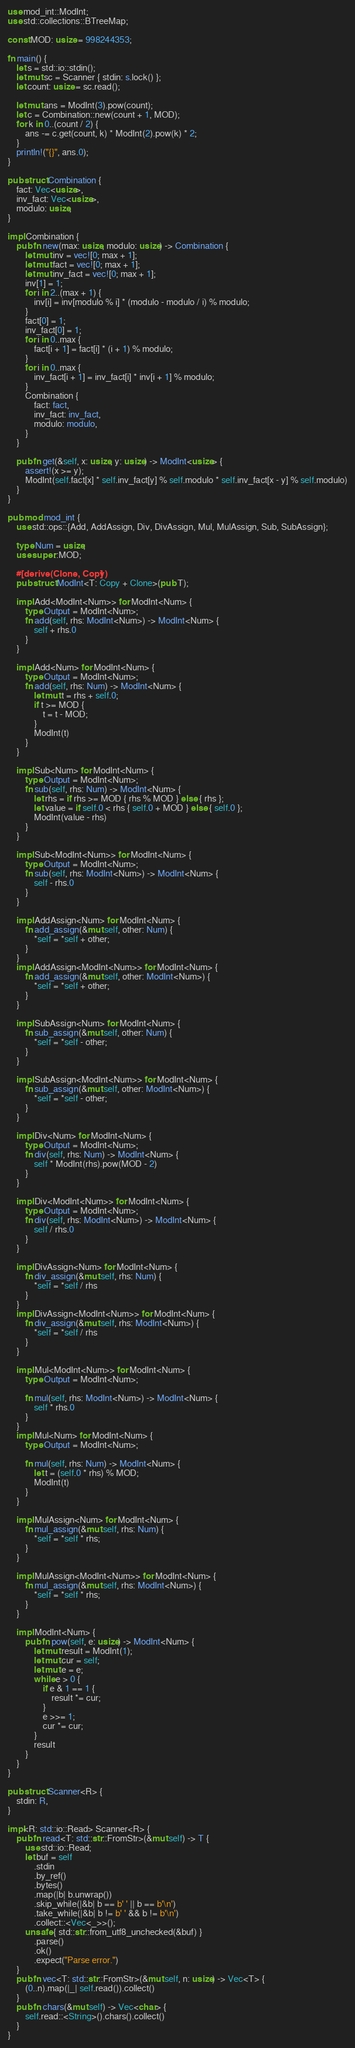<code> <loc_0><loc_0><loc_500><loc_500><_Rust_>use mod_int::ModInt;
use std::collections::BTreeMap;

const MOD: usize = 998244353;

fn main() {
    let s = std::io::stdin();
    let mut sc = Scanner { stdin: s.lock() };
    let count: usize = sc.read();

    let mut ans = ModInt(3).pow(count);
    let c = Combination::new(count + 1, MOD);
    for k in 0..(count / 2) {
        ans -= c.get(count, k) * ModInt(2).pow(k) * 2;
    }
    println!("{}", ans.0);
}

pub struct Combination {
    fact: Vec<usize>,
    inv_fact: Vec<usize>,
    modulo: usize,
}

impl Combination {
    pub fn new(max: usize, modulo: usize) -> Combination {
        let mut inv = vec![0; max + 1];
        let mut fact = vec![0; max + 1];
        let mut inv_fact = vec![0; max + 1];
        inv[1] = 1;
        for i in 2..(max + 1) {
            inv[i] = inv[modulo % i] * (modulo - modulo / i) % modulo;
        }
        fact[0] = 1;
        inv_fact[0] = 1;
        for i in 0..max {
            fact[i + 1] = fact[i] * (i + 1) % modulo;
        }
        for i in 0..max {
            inv_fact[i + 1] = inv_fact[i] * inv[i + 1] % modulo;
        }
        Combination {
            fact: fact,
            inv_fact: inv_fact,
            modulo: modulo,
        }
    }

    pub fn get(&self, x: usize, y: usize) -> ModInt<usize> {
        assert!(x >= y);
        ModInt(self.fact[x] * self.inv_fact[y] % self.modulo * self.inv_fact[x - y] % self.modulo)
    }
}

pub mod mod_int {
    use std::ops::{Add, AddAssign, Div, DivAssign, Mul, MulAssign, Sub, SubAssign};

    type Num = usize;
    use super::MOD;

    #[derive(Clone, Copy)]
    pub struct ModInt<T: Copy + Clone>(pub T);

    impl Add<ModInt<Num>> for ModInt<Num> {
        type Output = ModInt<Num>;
        fn add(self, rhs: ModInt<Num>) -> ModInt<Num> {
            self + rhs.0
        }
    }

    impl Add<Num> for ModInt<Num> {
        type Output = ModInt<Num>;
        fn add(self, rhs: Num) -> ModInt<Num> {
            let mut t = rhs + self.0;
            if t >= MOD {
                t = t - MOD;
            }
            ModInt(t)
        }
    }

    impl Sub<Num> for ModInt<Num> {
        type Output = ModInt<Num>;
        fn sub(self, rhs: Num) -> ModInt<Num> {
            let rhs = if rhs >= MOD { rhs % MOD } else { rhs };
            let value = if self.0 < rhs { self.0 + MOD } else { self.0 };
            ModInt(value - rhs)
        }
    }

    impl Sub<ModInt<Num>> for ModInt<Num> {
        type Output = ModInt<Num>;
        fn sub(self, rhs: ModInt<Num>) -> ModInt<Num> {
            self - rhs.0
        }
    }

    impl AddAssign<Num> for ModInt<Num> {
        fn add_assign(&mut self, other: Num) {
            *self = *self + other;
        }
    }
    impl AddAssign<ModInt<Num>> for ModInt<Num> {
        fn add_assign(&mut self, other: ModInt<Num>) {
            *self = *self + other;
        }
    }

    impl SubAssign<Num> for ModInt<Num> {
        fn sub_assign(&mut self, other: Num) {
            *self = *self - other;
        }
    }

    impl SubAssign<ModInt<Num>> for ModInt<Num> {
        fn sub_assign(&mut self, other: ModInt<Num>) {
            *self = *self - other;
        }
    }

    impl Div<Num> for ModInt<Num> {
        type Output = ModInt<Num>;
        fn div(self, rhs: Num) -> ModInt<Num> {
            self * ModInt(rhs).pow(MOD - 2)
        }
    }

    impl Div<ModInt<Num>> for ModInt<Num> {
        type Output = ModInt<Num>;
        fn div(self, rhs: ModInt<Num>) -> ModInt<Num> {
            self / rhs.0
        }
    }

    impl DivAssign<Num> for ModInt<Num> {
        fn div_assign(&mut self, rhs: Num) {
            *self = *self / rhs
        }
    }
    impl DivAssign<ModInt<Num>> for ModInt<Num> {
        fn div_assign(&mut self, rhs: ModInt<Num>) {
            *self = *self / rhs
        }
    }

    impl Mul<ModInt<Num>> for ModInt<Num> {
        type Output = ModInt<Num>;

        fn mul(self, rhs: ModInt<Num>) -> ModInt<Num> {
            self * rhs.0
        }
    }
    impl Mul<Num> for ModInt<Num> {
        type Output = ModInt<Num>;

        fn mul(self, rhs: Num) -> ModInt<Num> {
            let t = (self.0 * rhs) % MOD;
            ModInt(t)
        }
    }

    impl MulAssign<Num> for ModInt<Num> {
        fn mul_assign(&mut self, rhs: Num) {
            *self = *self * rhs;
        }
    }

    impl MulAssign<ModInt<Num>> for ModInt<Num> {
        fn mul_assign(&mut self, rhs: ModInt<Num>) {
            *self = *self * rhs;
        }
    }

    impl ModInt<Num> {
        pub fn pow(self, e: usize) -> ModInt<Num> {
            let mut result = ModInt(1);
            let mut cur = self;
            let mut e = e;
            while e > 0 {
                if e & 1 == 1 {
                    result *= cur;
                }
                e >>= 1;
                cur *= cur;
            }
            result
        }
    }
}

pub struct Scanner<R> {
    stdin: R,
}

impl<R: std::io::Read> Scanner<R> {
    pub fn read<T: std::str::FromStr>(&mut self) -> T {
        use std::io::Read;
        let buf = self
            .stdin
            .by_ref()
            .bytes()
            .map(|b| b.unwrap())
            .skip_while(|&b| b == b' ' || b == b'\n')
            .take_while(|&b| b != b' ' && b != b'\n')
            .collect::<Vec<_>>();
        unsafe { std::str::from_utf8_unchecked(&buf) }
            .parse()
            .ok()
            .expect("Parse error.")
    }
    pub fn vec<T: std::str::FromStr>(&mut self, n: usize) -> Vec<T> {
        (0..n).map(|_| self.read()).collect()
    }
    pub fn chars(&mut self) -> Vec<char> {
        self.read::<String>().chars().collect()
    }
}
</code> 